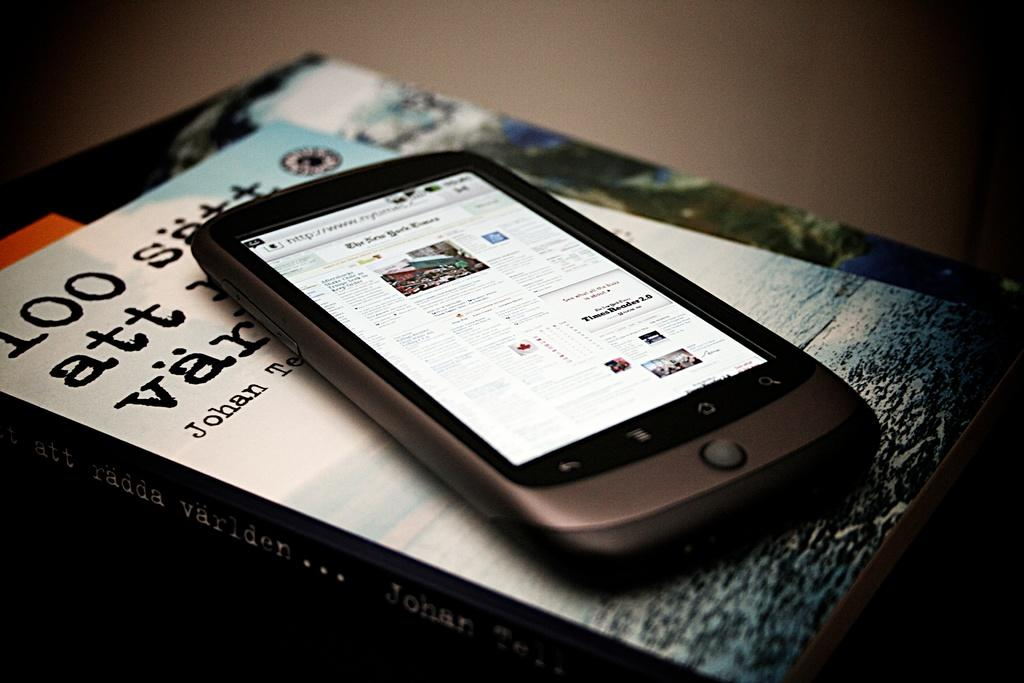<image>
Describe the image concisely. a smartphone is on top of a book with a new york times page open 